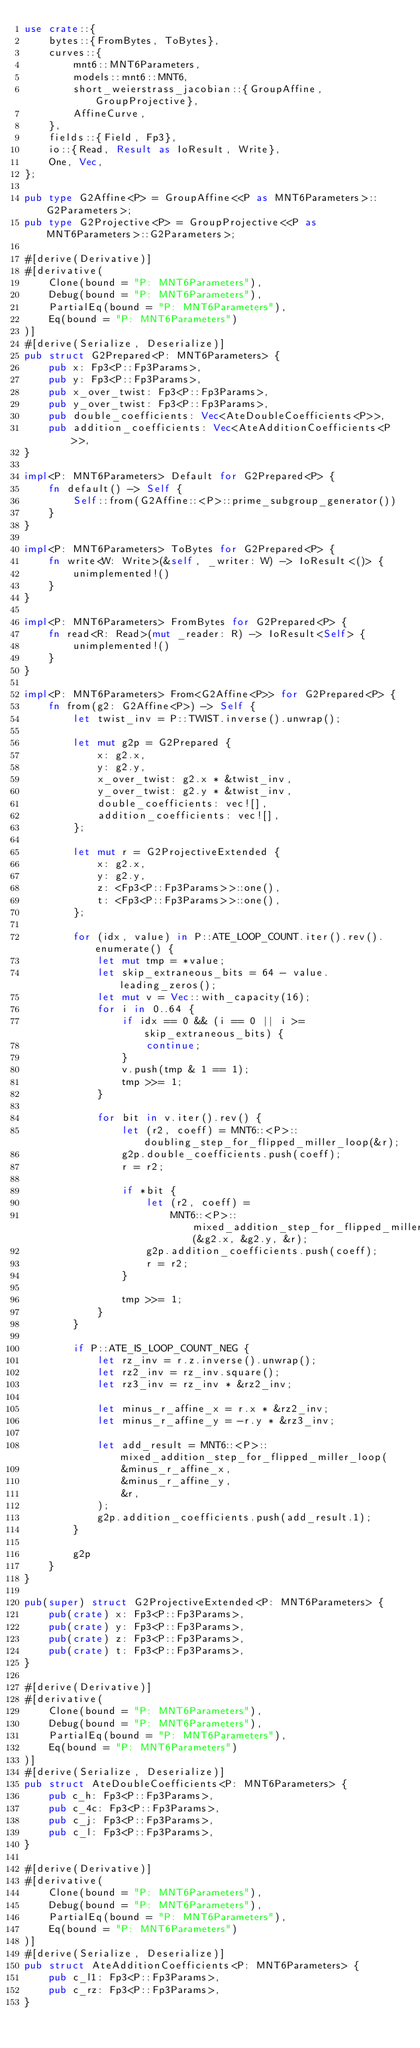Convert code to text. <code><loc_0><loc_0><loc_500><loc_500><_Rust_>use crate::{
    bytes::{FromBytes, ToBytes},
    curves::{
        mnt6::MNT6Parameters,
        models::mnt6::MNT6,
        short_weierstrass_jacobian::{GroupAffine, GroupProjective},
        AffineCurve,
    },
    fields::{Field, Fp3},
    io::{Read, Result as IoResult, Write},
    One, Vec,
};

pub type G2Affine<P> = GroupAffine<<P as MNT6Parameters>::G2Parameters>;
pub type G2Projective<P> = GroupProjective<<P as MNT6Parameters>::G2Parameters>;

#[derive(Derivative)]
#[derivative(
    Clone(bound = "P: MNT6Parameters"),
    Debug(bound = "P: MNT6Parameters"),
    PartialEq(bound = "P: MNT6Parameters"),
    Eq(bound = "P: MNT6Parameters")
)]
#[derive(Serialize, Deserialize)]
pub struct G2Prepared<P: MNT6Parameters> {
    pub x: Fp3<P::Fp3Params>,
    pub y: Fp3<P::Fp3Params>,
    pub x_over_twist: Fp3<P::Fp3Params>,
    pub y_over_twist: Fp3<P::Fp3Params>,
    pub double_coefficients: Vec<AteDoubleCoefficients<P>>,
    pub addition_coefficients: Vec<AteAdditionCoefficients<P>>,
}

impl<P: MNT6Parameters> Default for G2Prepared<P> {
    fn default() -> Self {
        Self::from(G2Affine::<P>::prime_subgroup_generator())
    }
}

impl<P: MNT6Parameters> ToBytes for G2Prepared<P> {
    fn write<W: Write>(&self, _writer: W) -> IoResult<()> {
        unimplemented!()
    }
}

impl<P: MNT6Parameters> FromBytes for G2Prepared<P> {
    fn read<R: Read>(mut _reader: R) -> IoResult<Self> {
        unimplemented!()
    }
}

impl<P: MNT6Parameters> From<G2Affine<P>> for G2Prepared<P> {
    fn from(g2: G2Affine<P>) -> Self {
        let twist_inv = P::TWIST.inverse().unwrap();

        let mut g2p = G2Prepared {
            x: g2.x,
            y: g2.y,
            x_over_twist: g2.x * &twist_inv,
            y_over_twist: g2.y * &twist_inv,
            double_coefficients: vec![],
            addition_coefficients: vec![],
        };

        let mut r = G2ProjectiveExtended {
            x: g2.x,
            y: g2.y,
            z: <Fp3<P::Fp3Params>>::one(),
            t: <Fp3<P::Fp3Params>>::one(),
        };

        for (idx, value) in P::ATE_LOOP_COUNT.iter().rev().enumerate() {
            let mut tmp = *value;
            let skip_extraneous_bits = 64 - value.leading_zeros();
            let mut v = Vec::with_capacity(16);
            for i in 0..64 {
                if idx == 0 && (i == 0 || i >= skip_extraneous_bits) {
                    continue;
                }
                v.push(tmp & 1 == 1);
                tmp >>= 1;
            }

            for bit in v.iter().rev() {
                let (r2, coeff) = MNT6::<P>::doubling_step_for_flipped_miller_loop(&r);
                g2p.double_coefficients.push(coeff);
                r = r2;

                if *bit {
                    let (r2, coeff) =
                        MNT6::<P>::mixed_addition_step_for_flipped_miller_loop(&g2.x, &g2.y, &r);
                    g2p.addition_coefficients.push(coeff);
                    r = r2;
                }

                tmp >>= 1;
            }
        }

        if P::ATE_IS_LOOP_COUNT_NEG {
            let rz_inv = r.z.inverse().unwrap();
            let rz2_inv = rz_inv.square();
            let rz3_inv = rz_inv * &rz2_inv;

            let minus_r_affine_x = r.x * &rz2_inv;
            let minus_r_affine_y = -r.y * &rz3_inv;

            let add_result = MNT6::<P>::mixed_addition_step_for_flipped_miller_loop(
                &minus_r_affine_x,
                &minus_r_affine_y,
                &r,
            );
            g2p.addition_coefficients.push(add_result.1);
        }

        g2p
    }
}

pub(super) struct G2ProjectiveExtended<P: MNT6Parameters> {
    pub(crate) x: Fp3<P::Fp3Params>,
    pub(crate) y: Fp3<P::Fp3Params>,
    pub(crate) z: Fp3<P::Fp3Params>,
    pub(crate) t: Fp3<P::Fp3Params>,
}

#[derive(Derivative)]
#[derivative(
    Clone(bound = "P: MNT6Parameters"),
    Debug(bound = "P: MNT6Parameters"),
    PartialEq(bound = "P: MNT6Parameters"),
    Eq(bound = "P: MNT6Parameters")
)]
#[derive(Serialize, Deserialize)]
pub struct AteDoubleCoefficients<P: MNT6Parameters> {
    pub c_h: Fp3<P::Fp3Params>,
    pub c_4c: Fp3<P::Fp3Params>,
    pub c_j: Fp3<P::Fp3Params>,
    pub c_l: Fp3<P::Fp3Params>,
}

#[derive(Derivative)]
#[derivative(
    Clone(bound = "P: MNT6Parameters"),
    Debug(bound = "P: MNT6Parameters"),
    PartialEq(bound = "P: MNT6Parameters"),
    Eq(bound = "P: MNT6Parameters")
)]
#[derive(Serialize, Deserialize)]
pub struct AteAdditionCoefficients<P: MNT6Parameters> {
    pub c_l1: Fp3<P::Fp3Params>,
    pub c_rz: Fp3<P::Fp3Params>,
}
</code> 